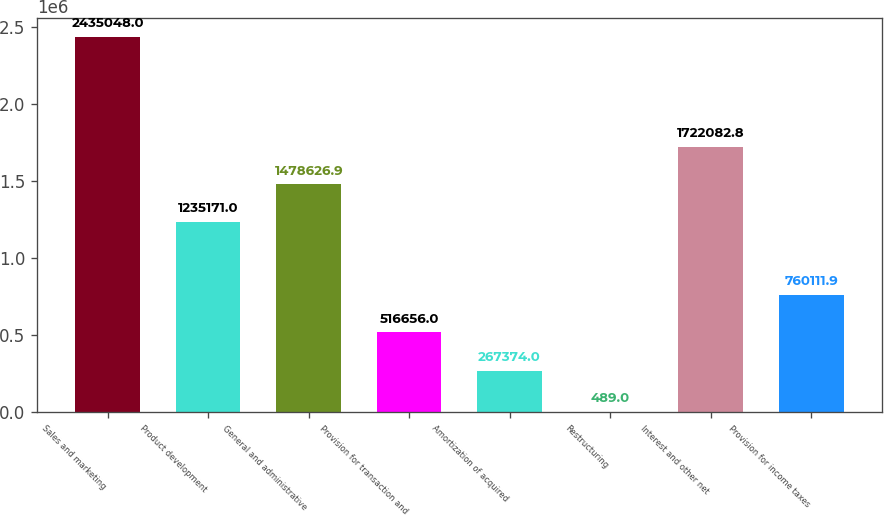Convert chart. <chart><loc_0><loc_0><loc_500><loc_500><bar_chart><fcel>Sales and marketing<fcel>Product development<fcel>General and administrative<fcel>Provision for transaction and<fcel>Amortization of acquired<fcel>Restructuring<fcel>Interest and other net<fcel>Provision for income taxes<nl><fcel>2.43505e+06<fcel>1.23517e+06<fcel>1.47863e+06<fcel>516656<fcel>267374<fcel>489<fcel>1.72208e+06<fcel>760112<nl></chart> 